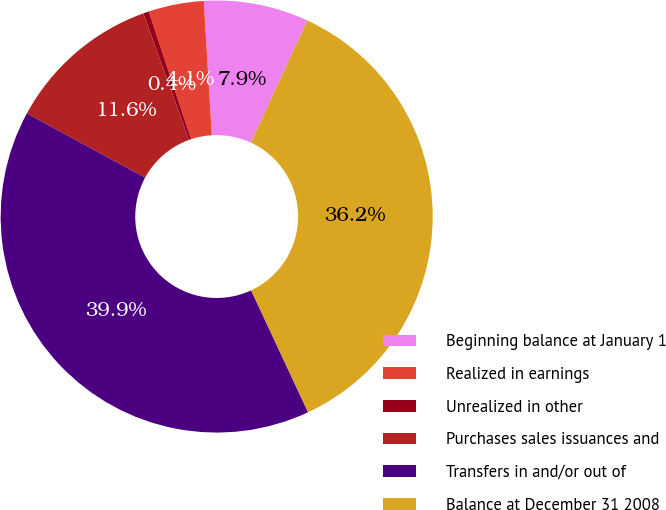Convert chart. <chart><loc_0><loc_0><loc_500><loc_500><pie_chart><fcel>Beginning balance at January 1<fcel>Realized in earnings<fcel>Unrealized in other<fcel>Purchases sales issuances and<fcel>Transfers in and/or out of<fcel>Balance at December 31 2008<nl><fcel>7.85%<fcel>4.14%<fcel>0.42%<fcel>11.57%<fcel>39.87%<fcel>36.15%<nl></chart> 